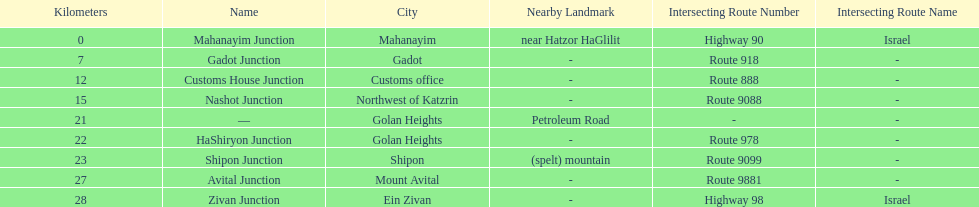What is the number of routes that intersect highway 91? 9. 